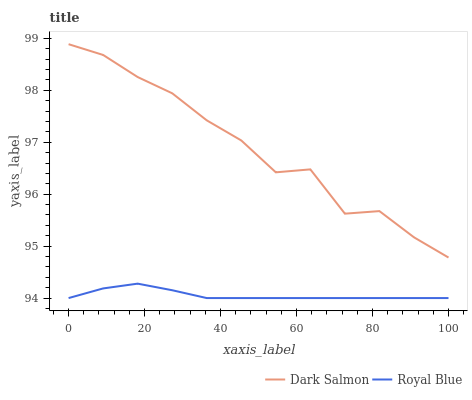Does Royal Blue have the minimum area under the curve?
Answer yes or no. Yes. Does Dark Salmon have the maximum area under the curve?
Answer yes or no. Yes. Does Dark Salmon have the minimum area under the curve?
Answer yes or no. No. Is Royal Blue the smoothest?
Answer yes or no. Yes. Is Dark Salmon the roughest?
Answer yes or no. Yes. Is Dark Salmon the smoothest?
Answer yes or no. No. Does Dark Salmon have the lowest value?
Answer yes or no. No. Is Royal Blue less than Dark Salmon?
Answer yes or no. Yes. Is Dark Salmon greater than Royal Blue?
Answer yes or no. Yes. Does Royal Blue intersect Dark Salmon?
Answer yes or no. No. 